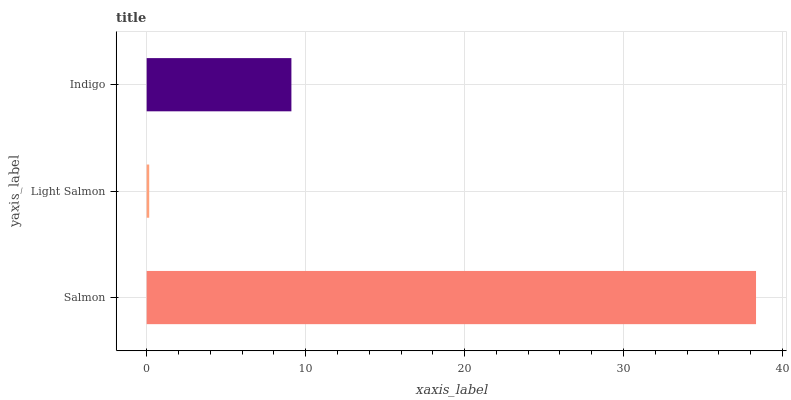Is Light Salmon the minimum?
Answer yes or no. Yes. Is Salmon the maximum?
Answer yes or no. Yes. Is Indigo the minimum?
Answer yes or no. No. Is Indigo the maximum?
Answer yes or no. No. Is Indigo greater than Light Salmon?
Answer yes or no. Yes. Is Light Salmon less than Indigo?
Answer yes or no. Yes. Is Light Salmon greater than Indigo?
Answer yes or no. No. Is Indigo less than Light Salmon?
Answer yes or no. No. Is Indigo the high median?
Answer yes or no. Yes. Is Indigo the low median?
Answer yes or no. Yes. Is Salmon the high median?
Answer yes or no. No. Is Salmon the low median?
Answer yes or no. No. 